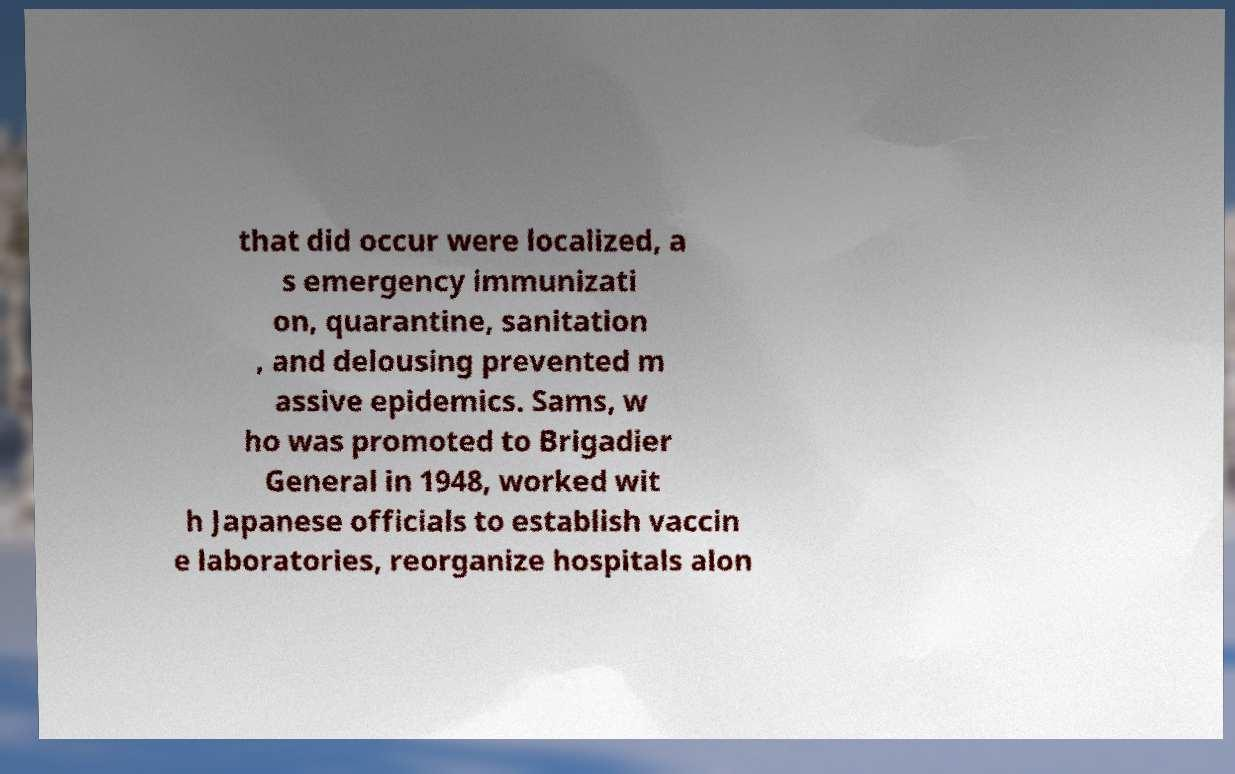Could you extract and type out the text from this image? that did occur were localized, a s emergency immunizati on, quarantine, sanitation , and delousing prevented m assive epidemics. Sams, w ho was promoted to Brigadier General in 1948, worked wit h Japanese officials to establish vaccin e laboratories, reorganize hospitals alon 